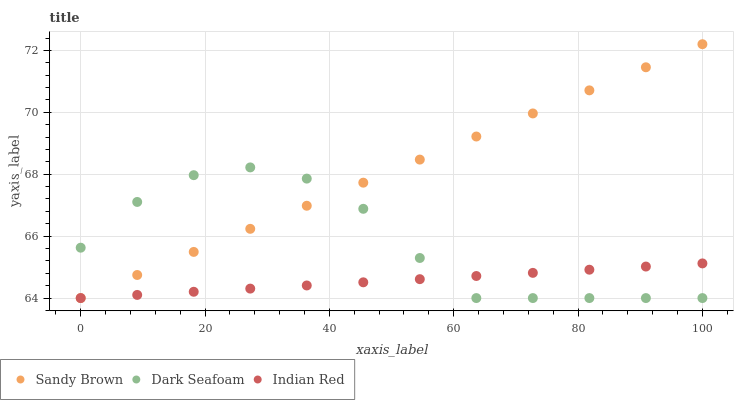Does Indian Red have the minimum area under the curve?
Answer yes or no. Yes. Does Sandy Brown have the maximum area under the curve?
Answer yes or no. Yes. Does Sandy Brown have the minimum area under the curve?
Answer yes or no. No. Does Indian Red have the maximum area under the curve?
Answer yes or no. No. Is Indian Red the smoothest?
Answer yes or no. Yes. Is Dark Seafoam the roughest?
Answer yes or no. Yes. Is Sandy Brown the smoothest?
Answer yes or no. No. Is Sandy Brown the roughest?
Answer yes or no. No. Does Dark Seafoam have the lowest value?
Answer yes or no. Yes. Does Sandy Brown have the highest value?
Answer yes or no. Yes. Does Indian Red have the highest value?
Answer yes or no. No. Does Dark Seafoam intersect Sandy Brown?
Answer yes or no. Yes. Is Dark Seafoam less than Sandy Brown?
Answer yes or no. No. Is Dark Seafoam greater than Sandy Brown?
Answer yes or no. No. 